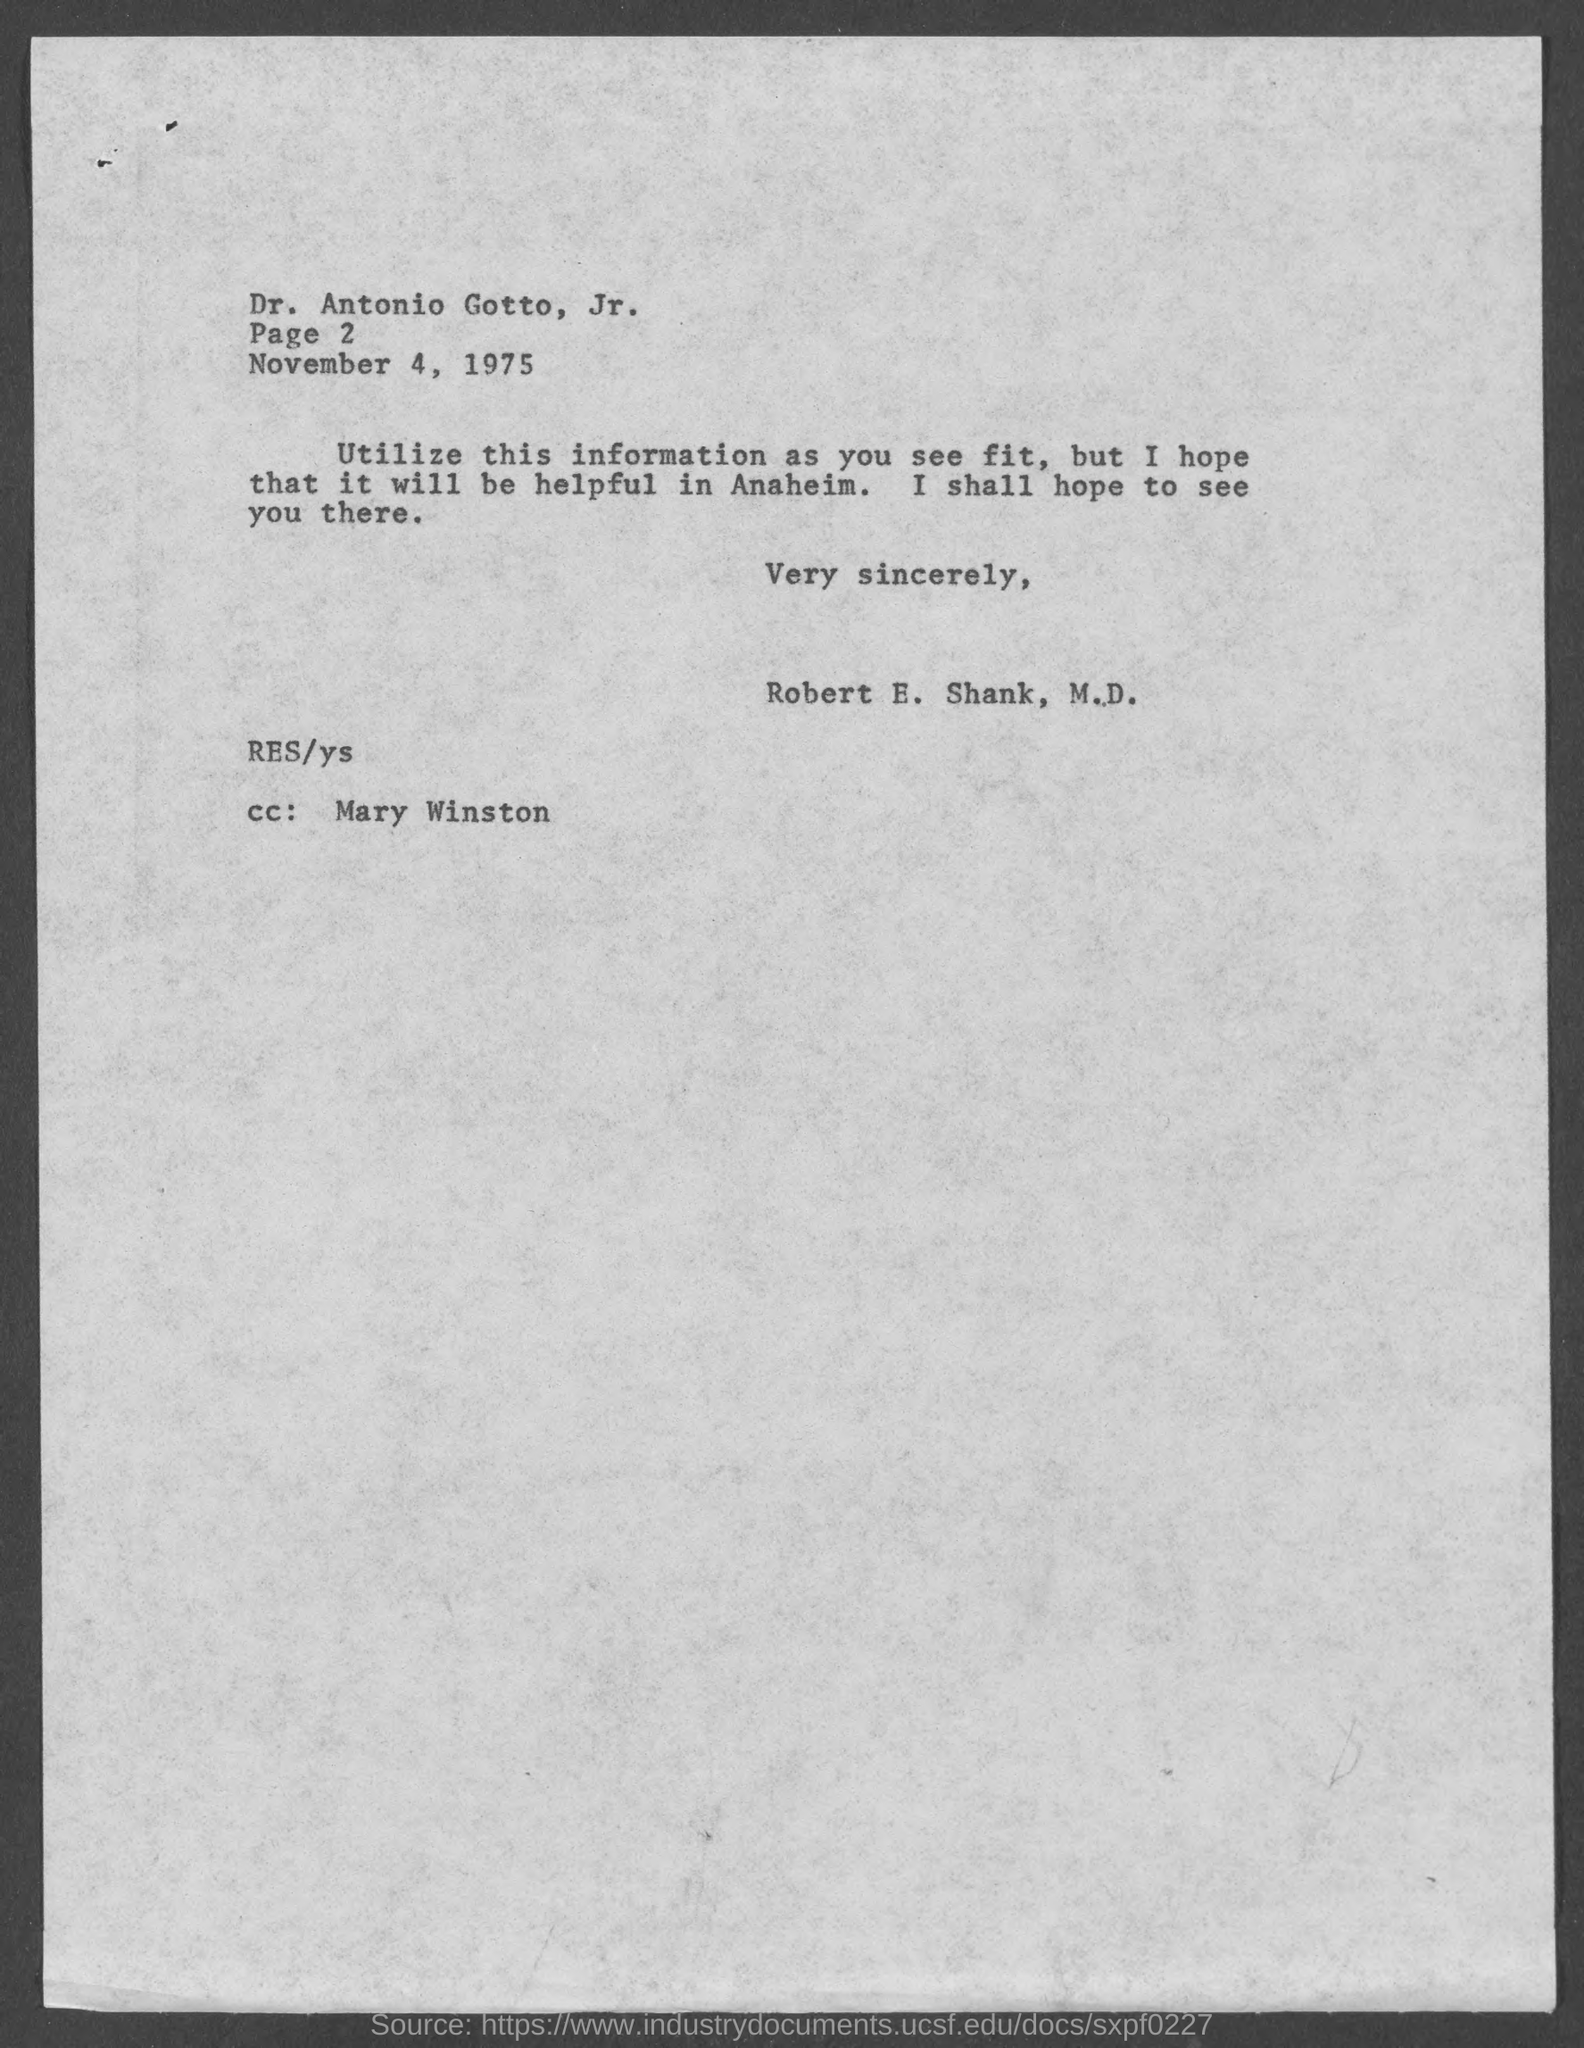What is the page no mentioned in this letter?
Your response must be concise. Page 2. What is the date mentioned in this letter?
Keep it short and to the point. November 4, 1975. Who is the sender of this letter?
Offer a very short reply. Robert E. Shank, M.D. Who is the addressee of this letter?
Your answer should be very brief. Dr. Antonio Gotto, Jr. Who is mentioned in the cc of this letter?
Provide a short and direct response. Mary Winston. 